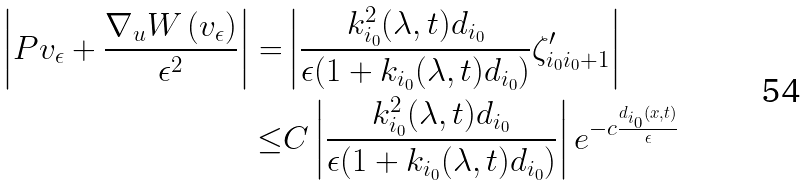Convert formula to latex. <formula><loc_0><loc_0><loc_500><loc_500>\left | P v _ { \epsilon } + \frac { \nabla _ { u } W \left ( v _ { \epsilon } \right ) } { \epsilon ^ { 2 } } \right | = & \left | \frac { k _ { i _ { 0 } } ^ { 2 } ( \lambda , t ) d _ { i _ { 0 } } } { \epsilon ( 1 + k _ { i _ { 0 } } ( \lambda , t ) d _ { i _ { 0 } } ) } \zeta ^ { \prime } _ { i _ { 0 } i _ { 0 } + 1 } \right | \\ \leq & C \left | \frac { k _ { i _ { 0 } } ^ { 2 } ( \lambda , t ) d _ { i _ { 0 } } } { \epsilon ( 1 + k _ { i _ { 0 } } ( \lambda , t ) d _ { i _ { 0 } } ) } \right | e ^ { - c \frac { d _ { i _ { 0 } } ( x , t ) } { \epsilon } }</formula> 